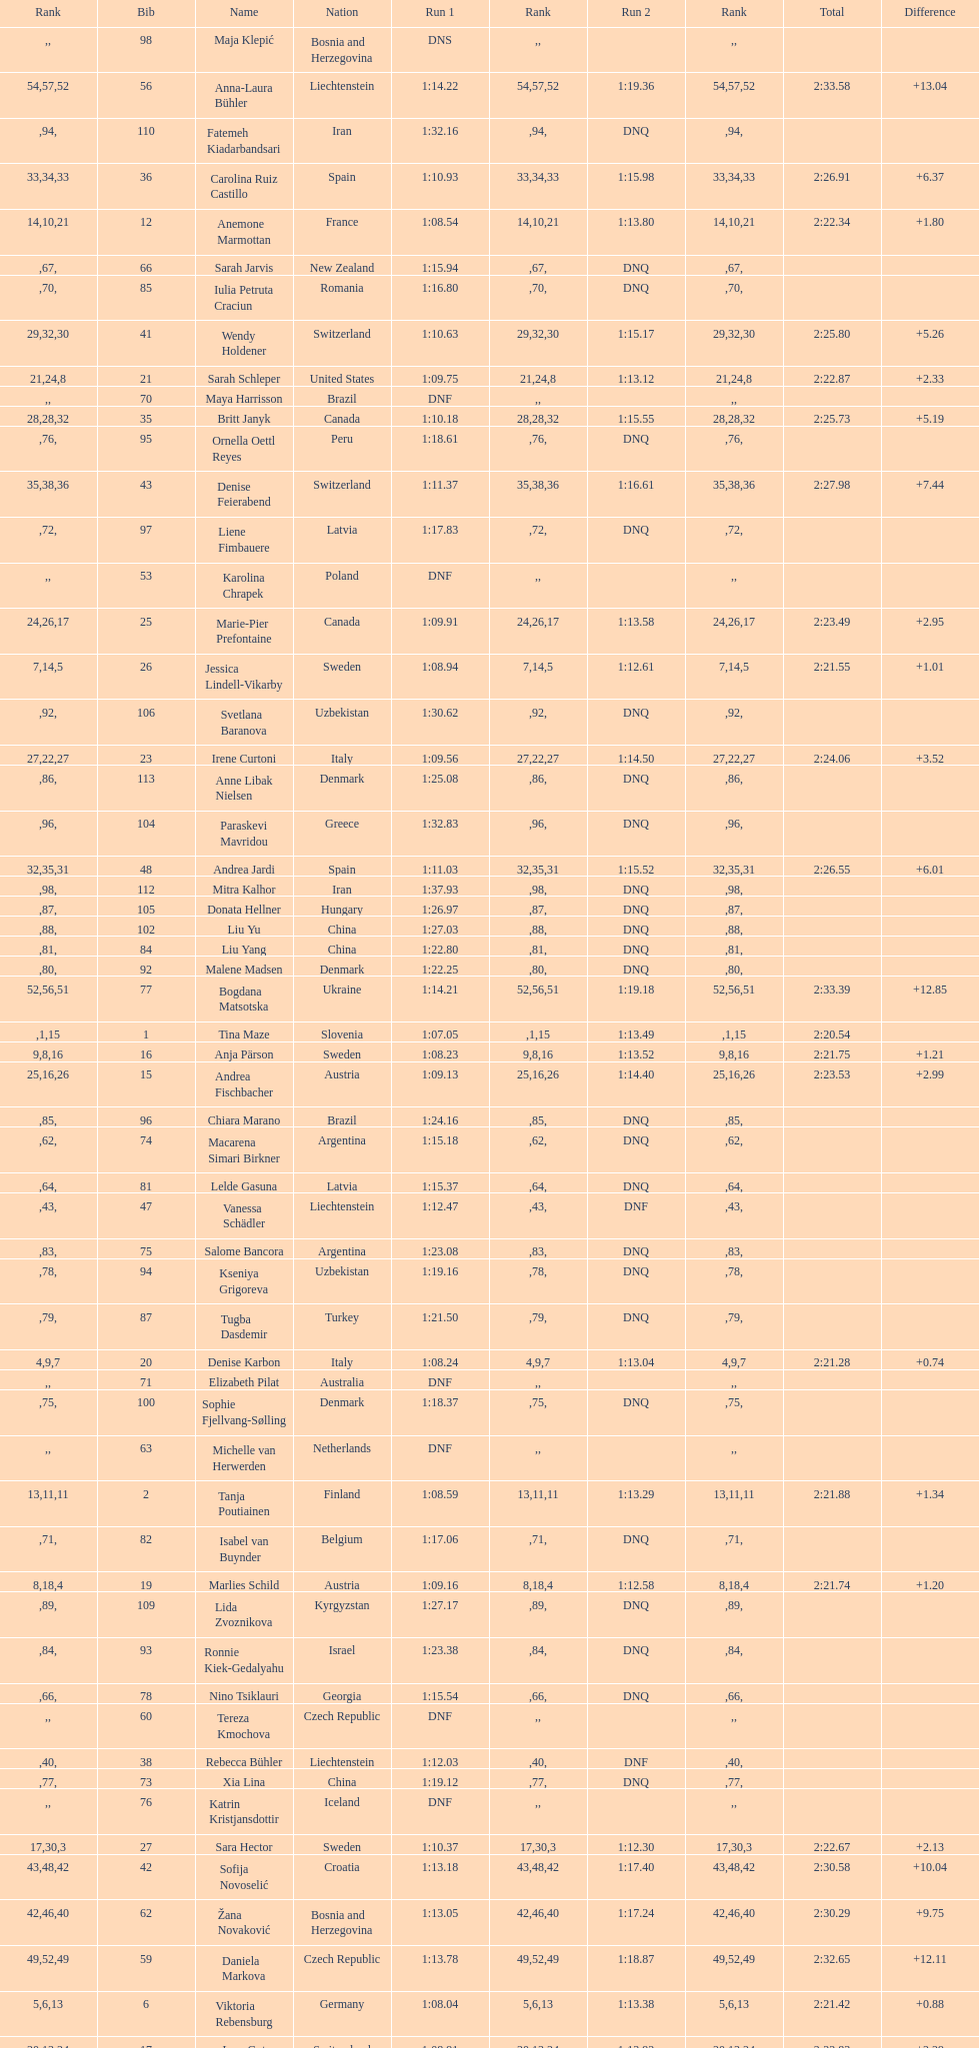Who was the last competitor to actually finish both runs? Martina Dubovska. 